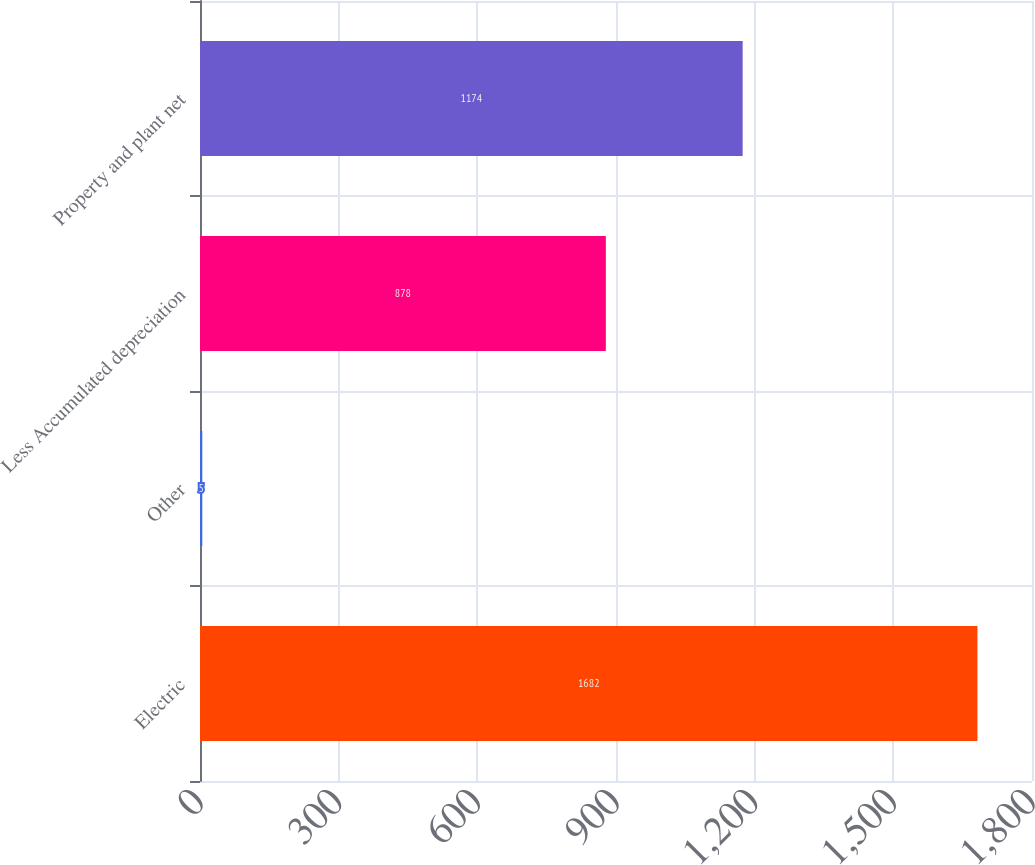Convert chart. <chart><loc_0><loc_0><loc_500><loc_500><bar_chart><fcel>Electric<fcel>Other<fcel>Less Accumulated depreciation<fcel>Property and plant net<nl><fcel>1682<fcel>5<fcel>878<fcel>1174<nl></chart> 